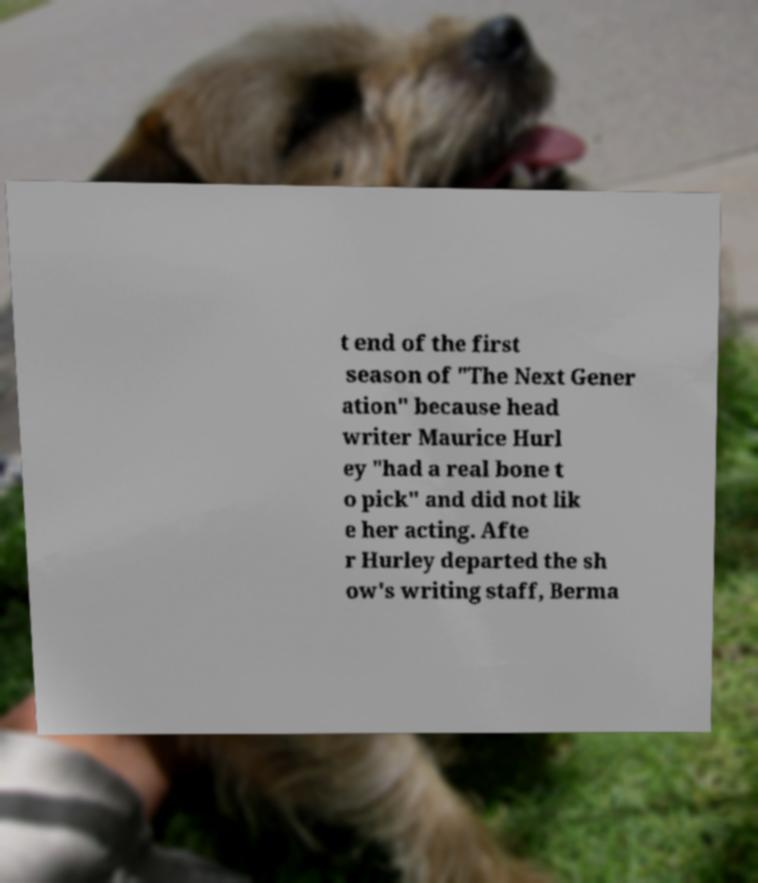There's text embedded in this image that I need extracted. Can you transcribe it verbatim? t end of the first season of "The Next Gener ation" because head writer Maurice Hurl ey "had a real bone t o pick" and did not lik e her acting. Afte r Hurley departed the sh ow's writing staff, Berma 